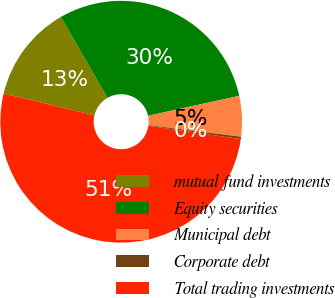Convert chart to OTSL. <chart><loc_0><loc_0><loc_500><loc_500><pie_chart><fcel>mutual fund investments<fcel>Equity securities<fcel>Municipal debt<fcel>Corporate debt<fcel>Total trading investments<nl><fcel>12.94%<fcel>29.88%<fcel>5.42%<fcel>0.31%<fcel>51.45%<nl></chart> 